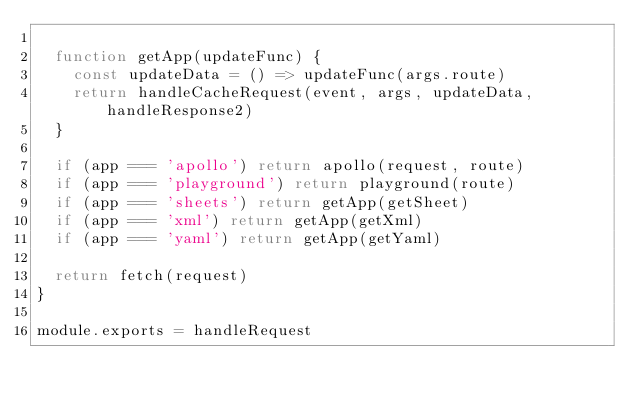Convert code to text. <code><loc_0><loc_0><loc_500><loc_500><_JavaScript_>
  function getApp(updateFunc) {
    const updateData = () => updateFunc(args.route)
    return handleCacheRequest(event, args, updateData, handleResponse2)
  }

  if (app === 'apollo') return apollo(request, route)
  if (app === 'playground') return playground(route)
  if (app === 'sheets') return getApp(getSheet)
  if (app === 'xml') return getApp(getXml)
  if (app === 'yaml') return getApp(getYaml)

  return fetch(request)
}

module.exports = handleRequest
</code> 